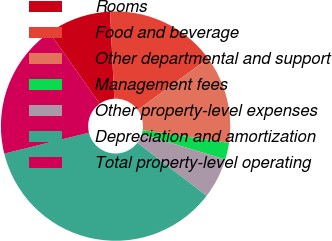<chart> <loc_0><loc_0><loc_500><loc_500><pie_chart><fcel>Rooms<fcel>Food and beverage<fcel>Other departmental and support<fcel>Management fees<fcel>Other property-level expenses<fcel>Depreciation and amortization<fcel>Total property-level operating<nl><fcel>9.04%<fcel>15.72%<fcel>12.38%<fcel>2.36%<fcel>5.7%<fcel>35.74%<fcel>19.05%<nl></chart> 